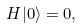Convert formula to latex. <formula><loc_0><loc_0><loc_500><loc_500>H | 0 \rangle = 0 ,</formula> 